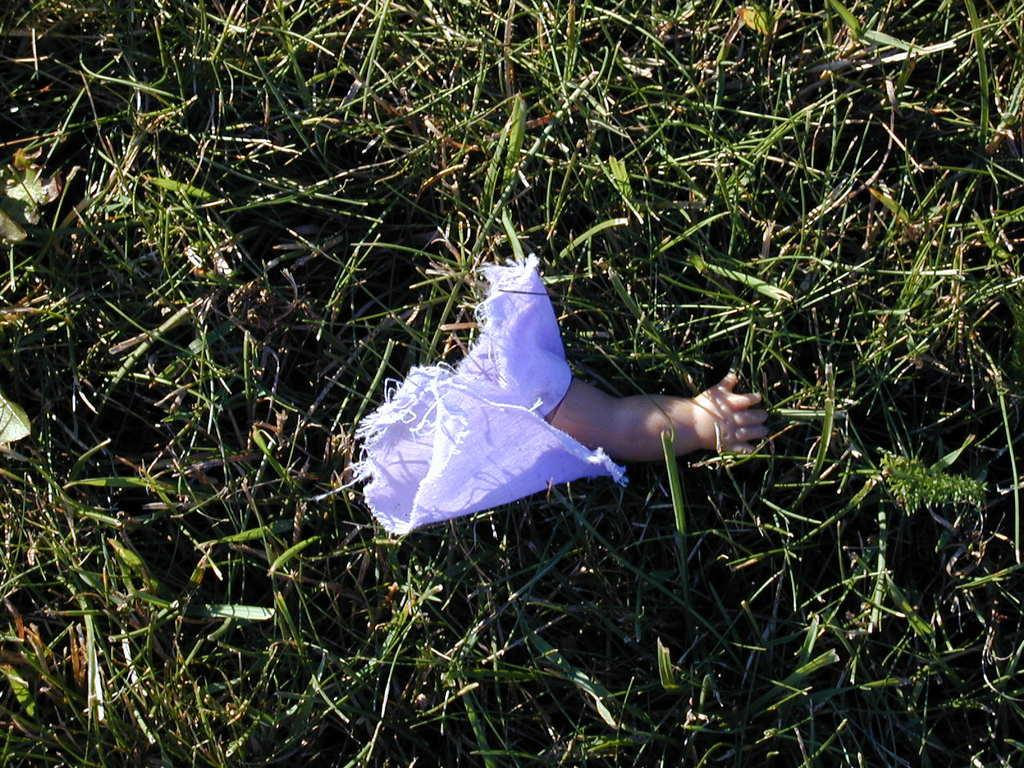What type of toy is in the image? There is a toy hand in the image. What material is present in the image? There is cloth in the image. Where are the toy hand and cloth located in the image? Both the toy hand and cloth are in the middle of the grass. How many ants can be seen crawling on the toy hand in the image? There are no ants present in the image; it only features a toy hand and cloth in the grass. 